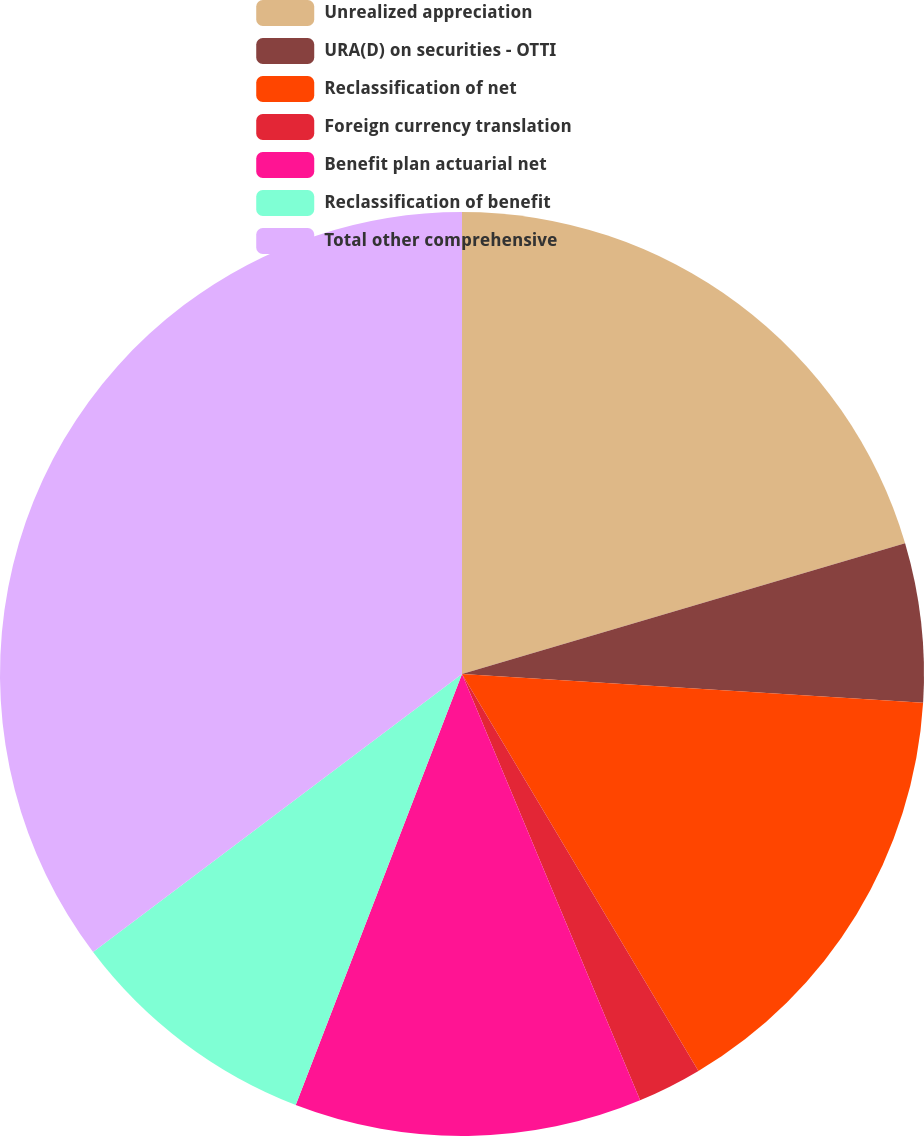<chart> <loc_0><loc_0><loc_500><loc_500><pie_chart><fcel>Unrealized appreciation<fcel>URA(D) on securities - OTTI<fcel>Reclassification of net<fcel>Foreign currency translation<fcel>Benefit plan actuarial net<fcel>Reclassification of benefit<fcel>Total other comprehensive<nl><fcel>20.43%<fcel>5.56%<fcel>15.46%<fcel>2.25%<fcel>12.16%<fcel>8.86%<fcel>35.28%<nl></chart> 